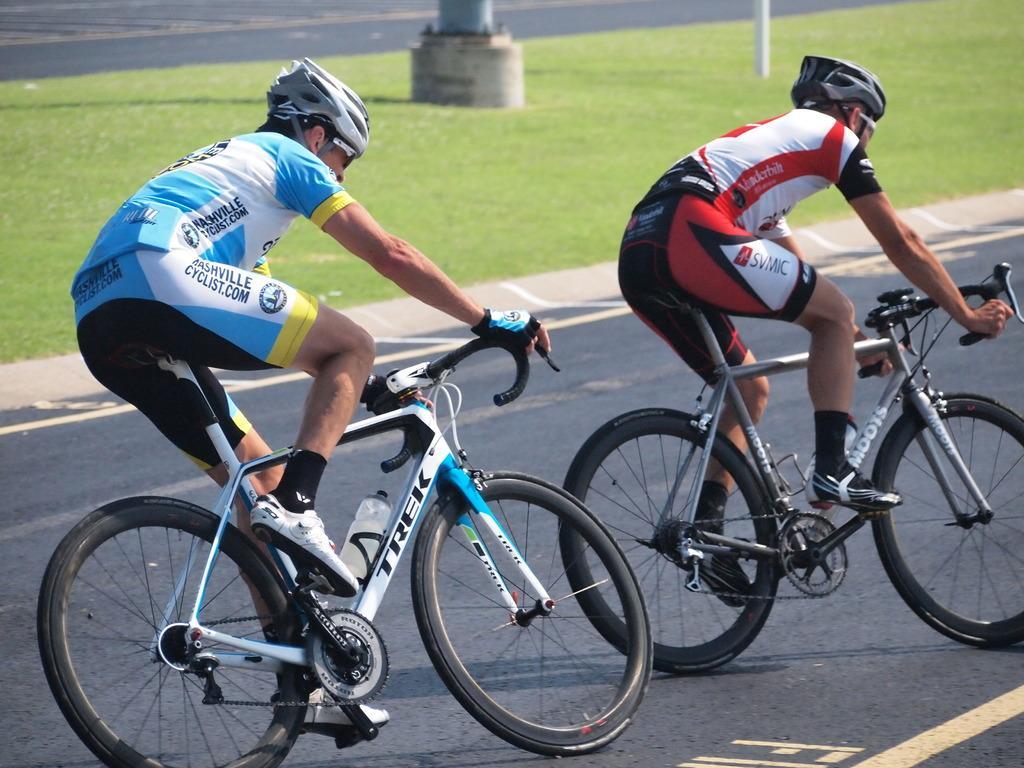In one or two sentences, can you explain what this image depicts? The man in white and blue T-shirt is riding the bicycle. In front of him, the man in white and red T-shirt is riding the bicycle on the road. Beside them, we see grass and a pole. Beside that, we see a white pole. 